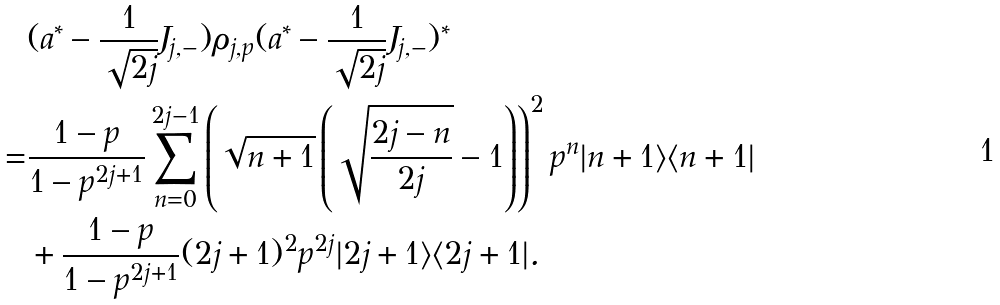<formula> <loc_0><loc_0><loc_500><loc_500>& ( a ^ { * } - \frac { 1 } { \sqrt { 2 j } } J _ { j , - } ) \rho _ { j , p } ( a ^ { * } - \frac { 1 } { \sqrt { 2 j } } J _ { j , - } ) ^ { * } \\ = & \frac { 1 - p } { 1 - p ^ { 2 j + 1 } } \sum _ { n = 0 } ^ { 2 j - 1 } \left ( \sqrt { n + 1 } \left ( \sqrt { \frac { 2 j - n } { 2 j } } - 1 \right ) \right ) ^ { 2 } p ^ { n } | n + 1 \rangle \langle n + 1 | \\ & + \frac { 1 - p } { 1 - p ^ { 2 j + 1 } } ( 2 j + 1 ) ^ { 2 } p ^ { 2 j } | 2 j + 1 \rangle \langle 2 j + 1 | .</formula> 